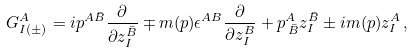<formula> <loc_0><loc_0><loc_500><loc_500>G ^ { A } _ { I ( \pm ) } = i p ^ { A { \bar { B } } } \frac { \partial } { \partial z _ { I } ^ { \bar { B } } } \mp m ( p ) \epsilon ^ { A B } \frac { \partial } { \partial z _ { I } ^ { B } } + p ^ { A } _ { \, \bar { B } } z _ { I } ^ { \bar { B } } \pm i m ( p ) z _ { I } ^ { A } \, ,</formula> 